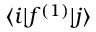<formula> <loc_0><loc_0><loc_500><loc_500>\langle i | f ^ { ( 1 ) } | j \rangle</formula> 